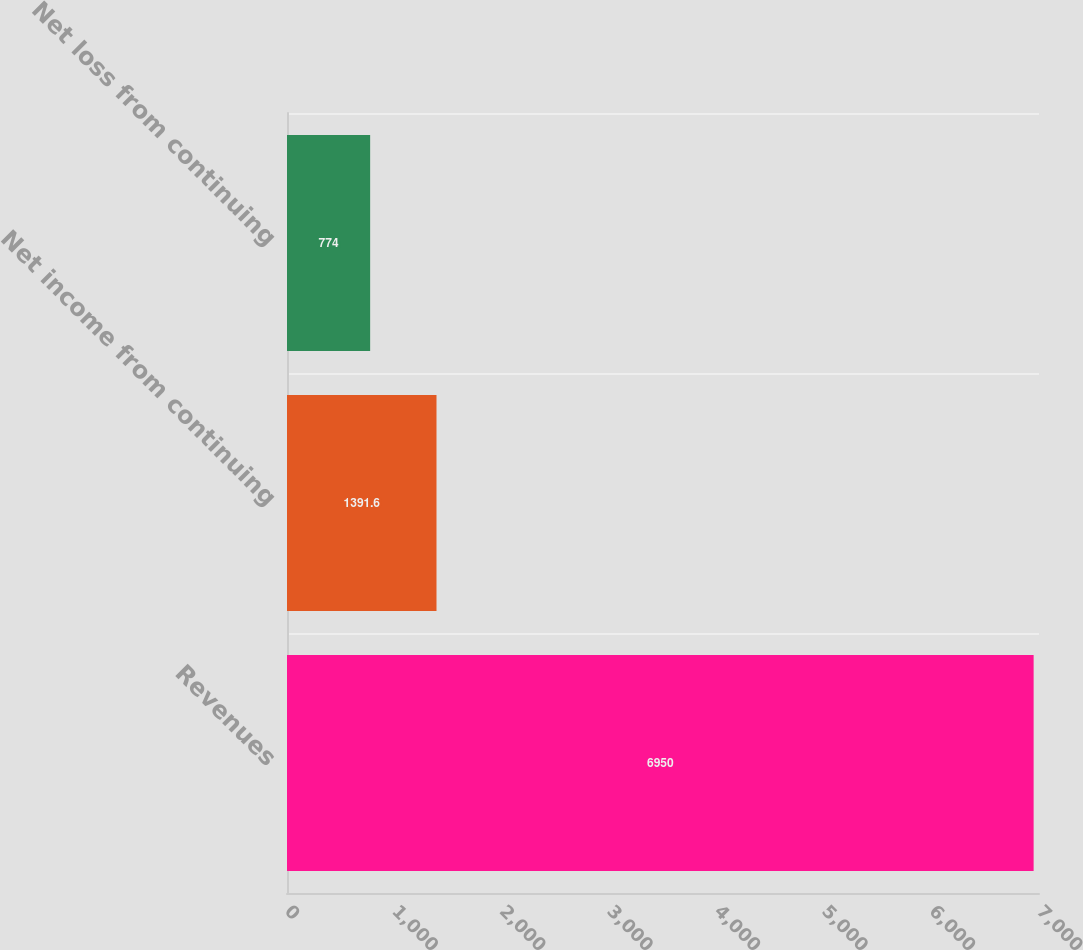Convert chart. <chart><loc_0><loc_0><loc_500><loc_500><bar_chart><fcel>Revenues<fcel>Net income from continuing<fcel>Net loss from continuing<nl><fcel>6950<fcel>1391.6<fcel>774<nl></chart> 